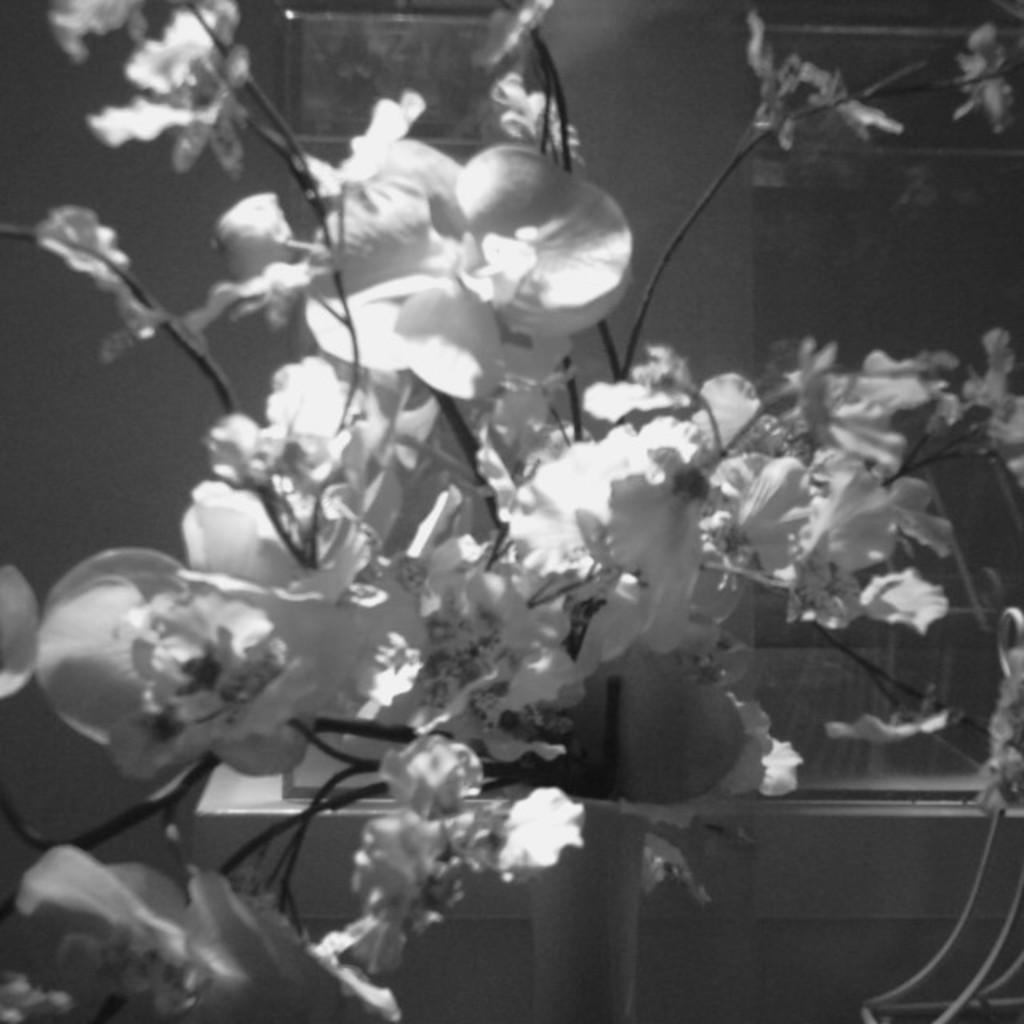Could you give a brief overview of what you see in this image? It is the black and white image in which we can see there are so many small flowers in the middle. 